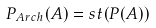Convert formula to latex. <formula><loc_0><loc_0><loc_500><loc_500>P _ { A r c h } ( A ) = s t ( P ( A ) )</formula> 